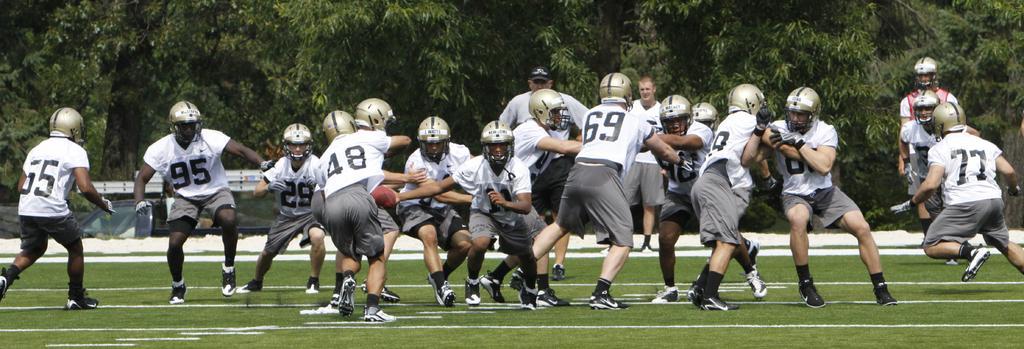Can you describe this image briefly? In this image I can see an open grass ground in the front and on it I can see white lines and number of people are standing. I can see all of them are wearing same colour of dress and helmets. On their dresses I can see few numbers are written. In the background I can see number of trees and few more people are standing. 